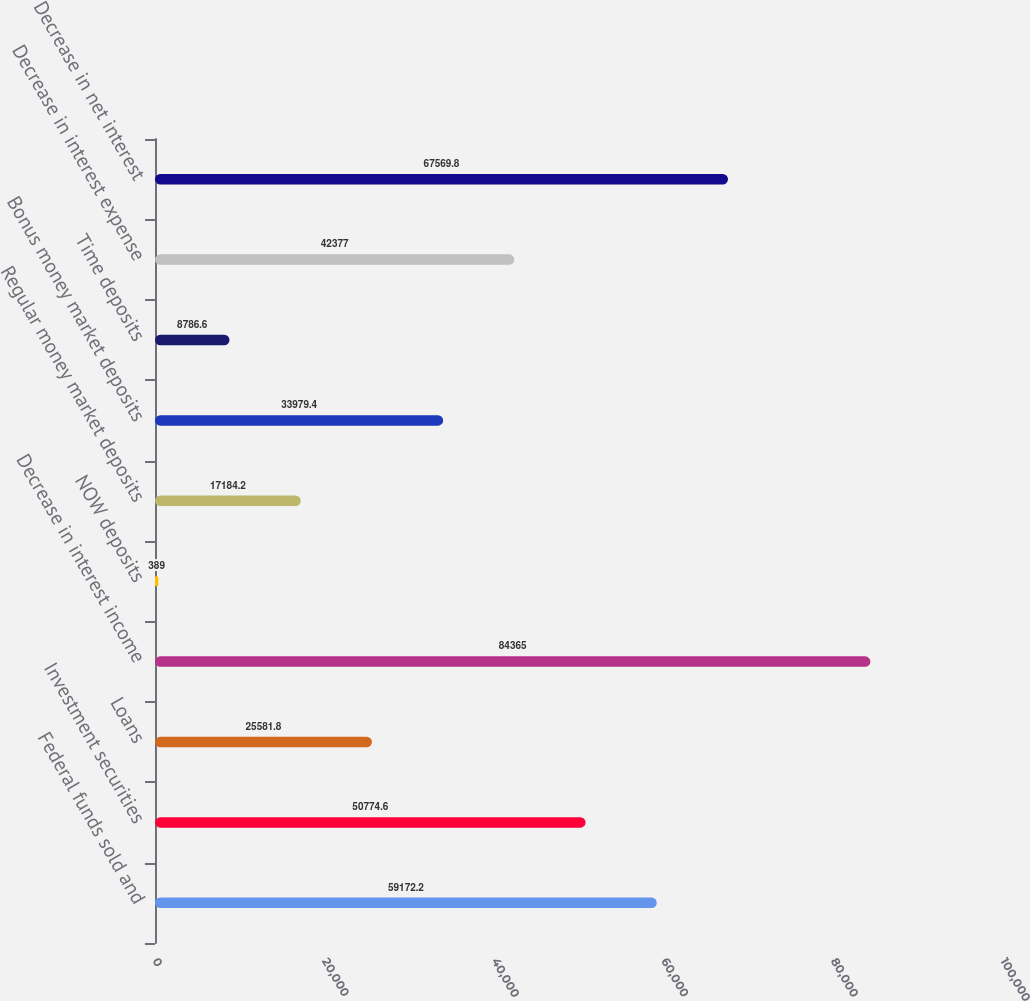Convert chart. <chart><loc_0><loc_0><loc_500><loc_500><bar_chart><fcel>Federal funds sold and<fcel>Investment securities<fcel>Loans<fcel>Decrease in interest income<fcel>NOW deposits<fcel>Regular money market deposits<fcel>Bonus money market deposits<fcel>Time deposits<fcel>Decrease in interest expense<fcel>Decrease in net interest<nl><fcel>59172.2<fcel>50774.6<fcel>25581.8<fcel>84365<fcel>389<fcel>17184.2<fcel>33979.4<fcel>8786.6<fcel>42377<fcel>67569.8<nl></chart> 